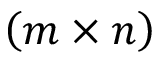<formula> <loc_0><loc_0><loc_500><loc_500>\left ( m \times n \right )</formula> 